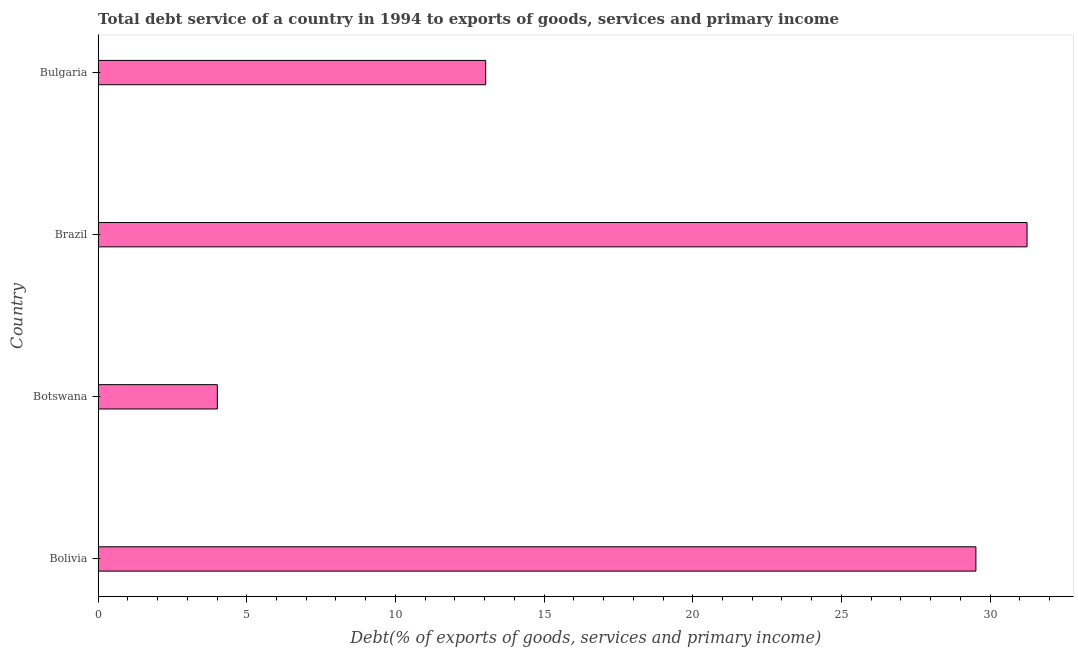Does the graph contain any zero values?
Give a very brief answer. No. What is the title of the graph?
Offer a very short reply. Total debt service of a country in 1994 to exports of goods, services and primary income. What is the label or title of the X-axis?
Your answer should be compact. Debt(% of exports of goods, services and primary income). What is the total debt service in Bulgaria?
Offer a very short reply. 13.04. Across all countries, what is the maximum total debt service?
Give a very brief answer. 31.24. Across all countries, what is the minimum total debt service?
Make the answer very short. 4.01. In which country was the total debt service maximum?
Your answer should be compact. Brazil. In which country was the total debt service minimum?
Offer a terse response. Botswana. What is the sum of the total debt service?
Your response must be concise. 77.81. What is the difference between the total debt service in Botswana and Bulgaria?
Your answer should be compact. -9.03. What is the average total debt service per country?
Offer a very short reply. 19.45. What is the median total debt service?
Your response must be concise. 21.28. What is the ratio of the total debt service in Botswana to that in Brazil?
Offer a terse response. 0.13. What is the difference between the highest and the second highest total debt service?
Your answer should be compact. 1.72. Is the sum of the total debt service in Botswana and Bulgaria greater than the maximum total debt service across all countries?
Offer a terse response. No. What is the difference between the highest and the lowest total debt service?
Make the answer very short. 27.23. How many bars are there?
Your answer should be very brief. 4. What is the difference between two consecutive major ticks on the X-axis?
Offer a terse response. 5. Are the values on the major ticks of X-axis written in scientific E-notation?
Provide a succinct answer. No. What is the Debt(% of exports of goods, services and primary income) in Bolivia?
Offer a terse response. 29.52. What is the Debt(% of exports of goods, services and primary income) in Botswana?
Your answer should be compact. 4.01. What is the Debt(% of exports of goods, services and primary income) of Brazil?
Your answer should be very brief. 31.24. What is the Debt(% of exports of goods, services and primary income) in Bulgaria?
Provide a short and direct response. 13.04. What is the difference between the Debt(% of exports of goods, services and primary income) in Bolivia and Botswana?
Give a very brief answer. 25.51. What is the difference between the Debt(% of exports of goods, services and primary income) in Bolivia and Brazil?
Offer a terse response. -1.72. What is the difference between the Debt(% of exports of goods, services and primary income) in Bolivia and Bulgaria?
Your answer should be very brief. 16.49. What is the difference between the Debt(% of exports of goods, services and primary income) in Botswana and Brazil?
Your answer should be compact. -27.23. What is the difference between the Debt(% of exports of goods, services and primary income) in Botswana and Bulgaria?
Provide a short and direct response. -9.03. What is the difference between the Debt(% of exports of goods, services and primary income) in Brazil and Bulgaria?
Ensure brevity in your answer.  18.21. What is the ratio of the Debt(% of exports of goods, services and primary income) in Bolivia to that in Botswana?
Your answer should be very brief. 7.36. What is the ratio of the Debt(% of exports of goods, services and primary income) in Bolivia to that in Brazil?
Keep it short and to the point. 0.94. What is the ratio of the Debt(% of exports of goods, services and primary income) in Bolivia to that in Bulgaria?
Make the answer very short. 2.27. What is the ratio of the Debt(% of exports of goods, services and primary income) in Botswana to that in Brazil?
Offer a terse response. 0.13. What is the ratio of the Debt(% of exports of goods, services and primary income) in Botswana to that in Bulgaria?
Your answer should be very brief. 0.31. What is the ratio of the Debt(% of exports of goods, services and primary income) in Brazil to that in Bulgaria?
Offer a very short reply. 2.4. 